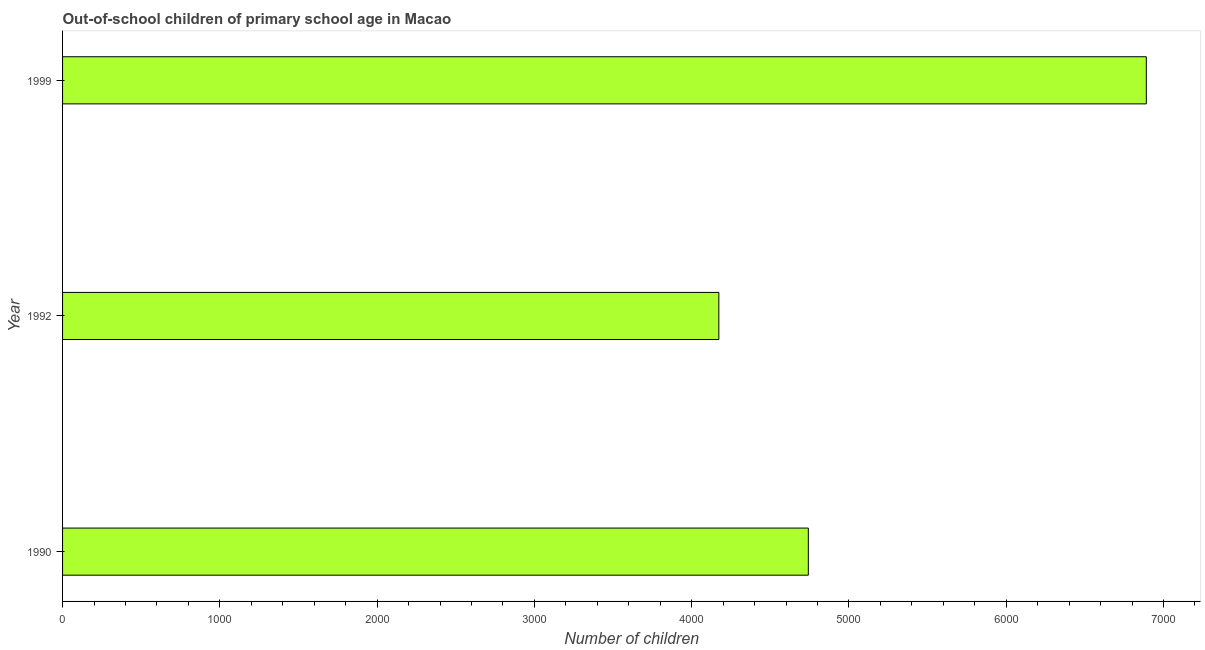Does the graph contain any zero values?
Ensure brevity in your answer.  No. What is the title of the graph?
Offer a very short reply. Out-of-school children of primary school age in Macao. What is the label or title of the X-axis?
Offer a very short reply. Number of children. What is the number of out-of-school children in 1999?
Give a very brief answer. 6891. Across all years, what is the maximum number of out-of-school children?
Provide a short and direct response. 6891. Across all years, what is the minimum number of out-of-school children?
Make the answer very short. 4173. What is the sum of the number of out-of-school children?
Your answer should be very brief. 1.58e+04. What is the difference between the number of out-of-school children in 1990 and 1999?
Give a very brief answer. -2149. What is the average number of out-of-school children per year?
Provide a succinct answer. 5268. What is the median number of out-of-school children?
Your answer should be very brief. 4742. Do a majority of the years between 1999 and 1990 (inclusive) have number of out-of-school children greater than 2200 ?
Provide a succinct answer. Yes. What is the ratio of the number of out-of-school children in 1992 to that in 1999?
Give a very brief answer. 0.61. What is the difference between the highest and the second highest number of out-of-school children?
Make the answer very short. 2149. Is the sum of the number of out-of-school children in 1992 and 1999 greater than the maximum number of out-of-school children across all years?
Your response must be concise. Yes. What is the difference between the highest and the lowest number of out-of-school children?
Offer a terse response. 2718. In how many years, is the number of out-of-school children greater than the average number of out-of-school children taken over all years?
Offer a terse response. 1. Are all the bars in the graph horizontal?
Offer a very short reply. Yes. What is the difference between two consecutive major ticks on the X-axis?
Offer a very short reply. 1000. Are the values on the major ticks of X-axis written in scientific E-notation?
Your answer should be very brief. No. What is the Number of children of 1990?
Your response must be concise. 4742. What is the Number of children of 1992?
Keep it short and to the point. 4173. What is the Number of children in 1999?
Provide a succinct answer. 6891. What is the difference between the Number of children in 1990 and 1992?
Offer a terse response. 569. What is the difference between the Number of children in 1990 and 1999?
Your response must be concise. -2149. What is the difference between the Number of children in 1992 and 1999?
Make the answer very short. -2718. What is the ratio of the Number of children in 1990 to that in 1992?
Ensure brevity in your answer.  1.14. What is the ratio of the Number of children in 1990 to that in 1999?
Your answer should be compact. 0.69. What is the ratio of the Number of children in 1992 to that in 1999?
Offer a very short reply. 0.61. 